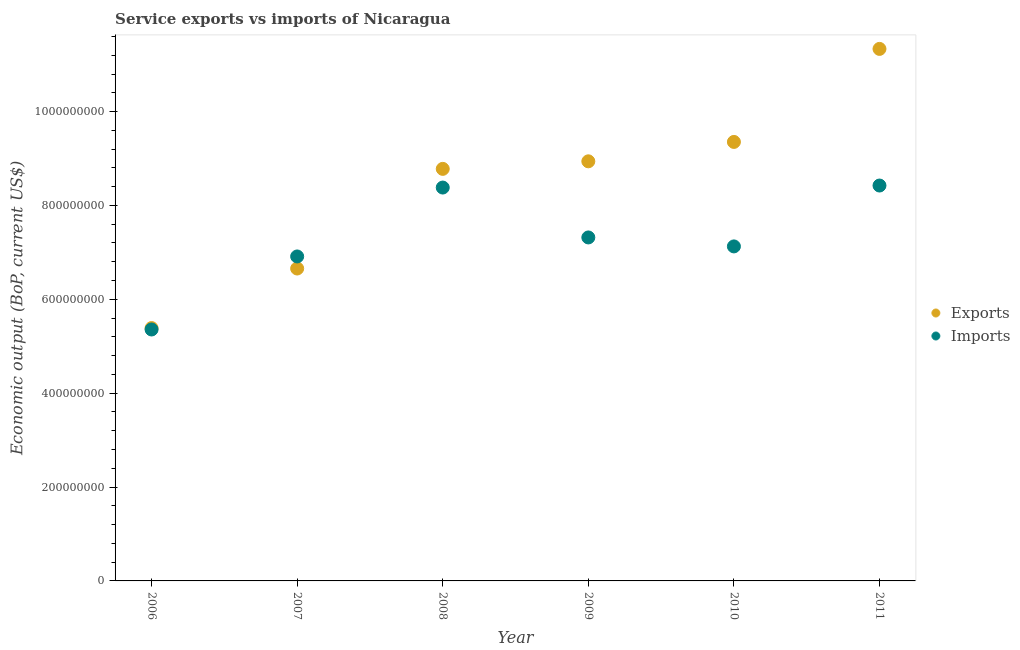How many different coloured dotlines are there?
Make the answer very short. 2. Is the number of dotlines equal to the number of legend labels?
Offer a very short reply. Yes. What is the amount of service exports in 2006?
Give a very brief answer. 5.39e+08. Across all years, what is the maximum amount of service imports?
Make the answer very short. 8.42e+08. Across all years, what is the minimum amount of service exports?
Your answer should be very brief. 5.39e+08. In which year was the amount of service exports maximum?
Your response must be concise. 2011. What is the total amount of service imports in the graph?
Provide a succinct answer. 4.35e+09. What is the difference between the amount of service exports in 2009 and that in 2010?
Provide a short and direct response. -4.13e+07. What is the difference between the amount of service exports in 2011 and the amount of service imports in 2007?
Provide a short and direct response. 4.42e+08. What is the average amount of service exports per year?
Your answer should be very brief. 8.41e+08. In the year 2007, what is the difference between the amount of service imports and amount of service exports?
Offer a terse response. 2.57e+07. In how many years, is the amount of service imports greater than 1080000000 US$?
Your response must be concise. 0. What is the ratio of the amount of service imports in 2007 to that in 2011?
Offer a very short reply. 0.82. What is the difference between the highest and the second highest amount of service imports?
Provide a succinct answer. 4.30e+06. What is the difference between the highest and the lowest amount of service exports?
Ensure brevity in your answer.  5.95e+08. Is the sum of the amount of service exports in 2008 and 2009 greater than the maximum amount of service imports across all years?
Give a very brief answer. Yes. How many dotlines are there?
Offer a very short reply. 2. Are the values on the major ticks of Y-axis written in scientific E-notation?
Your answer should be very brief. No. Does the graph contain grids?
Give a very brief answer. No. Where does the legend appear in the graph?
Provide a short and direct response. Center right. What is the title of the graph?
Keep it short and to the point. Service exports vs imports of Nicaragua. Does "Travel Items" appear as one of the legend labels in the graph?
Ensure brevity in your answer.  No. What is the label or title of the Y-axis?
Your answer should be compact. Economic output (BoP, current US$). What is the Economic output (BoP, current US$) of Exports in 2006?
Make the answer very short. 5.39e+08. What is the Economic output (BoP, current US$) of Imports in 2006?
Provide a succinct answer. 5.36e+08. What is the Economic output (BoP, current US$) in Exports in 2007?
Your answer should be compact. 6.66e+08. What is the Economic output (BoP, current US$) in Imports in 2007?
Give a very brief answer. 6.91e+08. What is the Economic output (BoP, current US$) of Exports in 2008?
Keep it short and to the point. 8.78e+08. What is the Economic output (BoP, current US$) in Imports in 2008?
Your answer should be very brief. 8.38e+08. What is the Economic output (BoP, current US$) of Exports in 2009?
Offer a terse response. 8.94e+08. What is the Economic output (BoP, current US$) in Imports in 2009?
Give a very brief answer. 7.32e+08. What is the Economic output (BoP, current US$) in Exports in 2010?
Offer a very short reply. 9.35e+08. What is the Economic output (BoP, current US$) of Imports in 2010?
Your response must be concise. 7.13e+08. What is the Economic output (BoP, current US$) of Exports in 2011?
Provide a succinct answer. 1.13e+09. What is the Economic output (BoP, current US$) in Imports in 2011?
Provide a succinct answer. 8.42e+08. Across all years, what is the maximum Economic output (BoP, current US$) in Exports?
Make the answer very short. 1.13e+09. Across all years, what is the maximum Economic output (BoP, current US$) in Imports?
Keep it short and to the point. 8.42e+08. Across all years, what is the minimum Economic output (BoP, current US$) of Exports?
Ensure brevity in your answer.  5.39e+08. Across all years, what is the minimum Economic output (BoP, current US$) in Imports?
Keep it short and to the point. 5.36e+08. What is the total Economic output (BoP, current US$) in Exports in the graph?
Keep it short and to the point. 5.04e+09. What is the total Economic output (BoP, current US$) in Imports in the graph?
Offer a very short reply. 4.35e+09. What is the difference between the Economic output (BoP, current US$) in Exports in 2006 and that in 2007?
Provide a succinct answer. -1.27e+08. What is the difference between the Economic output (BoP, current US$) of Imports in 2006 and that in 2007?
Offer a terse response. -1.56e+08. What is the difference between the Economic output (BoP, current US$) in Exports in 2006 and that in 2008?
Give a very brief answer. -3.39e+08. What is the difference between the Economic output (BoP, current US$) in Imports in 2006 and that in 2008?
Give a very brief answer. -3.02e+08. What is the difference between the Economic output (BoP, current US$) in Exports in 2006 and that in 2009?
Ensure brevity in your answer.  -3.55e+08. What is the difference between the Economic output (BoP, current US$) in Imports in 2006 and that in 2009?
Keep it short and to the point. -1.96e+08. What is the difference between the Economic output (BoP, current US$) in Exports in 2006 and that in 2010?
Your response must be concise. -3.97e+08. What is the difference between the Economic output (BoP, current US$) in Imports in 2006 and that in 2010?
Your response must be concise. -1.77e+08. What is the difference between the Economic output (BoP, current US$) of Exports in 2006 and that in 2011?
Provide a short and direct response. -5.95e+08. What is the difference between the Economic output (BoP, current US$) in Imports in 2006 and that in 2011?
Provide a short and direct response. -3.07e+08. What is the difference between the Economic output (BoP, current US$) in Exports in 2007 and that in 2008?
Provide a succinct answer. -2.12e+08. What is the difference between the Economic output (BoP, current US$) of Imports in 2007 and that in 2008?
Ensure brevity in your answer.  -1.47e+08. What is the difference between the Economic output (BoP, current US$) of Exports in 2007 and that in 2009?
Offer a very short reply. -2.28e+08. What is the difference between the Economic output (BoP, current US$) of Imports in 2007 and that in 2009?
Ensure brevity in your answer.  -4.05e+07. What is the difference between the Economic output (BoP, current US$) in Exports in 2007 and that in 2010?
Offer a very short reply. -2.70e+08. What is the difference between the Economic output (BoP, current US$) in Imports in 2007 and that in 2010?
Keep it short and to the point. -2.14e+07. What is the difference between the Economic output (BoP, current US$) in Exports in 2007 and that in 2011?
Your answer should be very brief. -4.68e+08. What is the difference between the Economic output (BoP, current US$) in Imports in 2007 and that in 2011?
Your response must be concise. -1.51e+08. What is the difference between the Economic output (BoP, current US$) in Exports in 2008 and that in 2009?
Your response must be concise. -1.61e+07. What is the difference between the Economic output (BoP, current US$) of Imports in 2008 and that in 2009?
Make the answer very short. 1.06e+08. What is the difference between the Economic output (BoP, current US$) of Exports in 2008 and that in 2010?
Provide a short and direct response. -5.74e+07. What is the difference between the Economic output (BoP, current US$) in Imports in 2008 and that in 2010?
Keep it short and to the point. 1.25e+08. What is the difference between the Economic output (BoP, current US$) in Exports in 2008 and that in 2011?
Keep it short and to the point. -2.56e+08. What is the difference between the Economic output (BoP, current US$) in Imports in 2008 and that in 2011?
Ensure brevity in your answer.  -4.30e+06. What is the difference between the Economic output (BoP, current US$) in Exports in 2009 and that in 2010?
Make the answer very short. -4.13e+07. What is the difference between the Economic output (BoP, current US$) of Imports in 2009 and that in 2010?
Ensure brevity in your answer.  1.91e+07. What is the difference between the Economic output (BoP, current US$) in Exports in 2009 and that in 2011?
Offer a very short reply. -2.40e+08. What is the difference between the Economic output (BoP, current US$) of Imports in 2009 and that in 2011?
Ensure brevity in your answer.  -1.11e+08. What is the difference between the Economic output (BoP, current US$) in Exports in 2010 and that in 2011?
Make the answer very short. -1.98e+08. What is the difference between the Economic output (BoP, current US$) in Imports in 2010 and that in 2011?
Give a very brief answer. -1.30e+08. What is the difference between the Economic output (BoP, current US$) of Exports in 2006 and the Economic output (BoP, current US$) of Imports in 2007?
Provide a short and direct response. -1.53e+08. What is the difference between the Economic output (BoP, current US$) of Exports in 2006 and the Economic output (BoP, current US$) of Imports in 2008?
Make the answer very short. -2.99e+08. What is the difference between the Economic output (BoP, current US$) in Exports in 2006 and the Economic output (BoP, current US$) in Imports in 2009?
Give a very brief answer. -1.93e+08. What is the difference between the Economic output (BoP, current US$) in Exports in 2006 and the Economic output (BoP, current US$) in Imports in 2010?
Offer a very short reply. -1.74e+08. What is the difference between the Economic output (BoP, current US$) in Exports in 2006 and the Economic output (BoP, current US$) in Imports in 2011?
Give a very brief answer. -3.04e+08. What is the difference between the Economic output (BoP, current US$) of Exports in 2007 and the Economic output (BoP, current US$) of Imports in 2008?
Your answer should be very brief. -1.72e+08. What is the difference between the Economic output (BoP, current US$) of Exports in 2007 and the Economic output (BoP, current US$) of Imports in 2009?
Ensure brevity in your answer.  -6.62e+07. What is the difference between the Economic output (BoP, current US$) in Exports in 2007 and the Economic output (BoP, current US$) in Imports in 2010?
Provide a succinct answer. -4.71e+07. What is the difference between the Economic output (BoP, current US$) in Exports in 2007 and the Economic output (BoP, current US$) in Imports in 2011?
Offer a very short reply. -1.77e+08. What is the difference between the Economic output (BoP, current US$) of Exports in 2008 and the Economic output (BoP, current US$) of Imports in 2009?
Your answer should be compact. 1.46e+08. What is the difference between the Economic output (BoP, current US$) of Exports in 2008 and the Economic output (BoP, current US$) of Imports in 2010?
Provide a succinct answer. 1.65e+08. What is the difference between the Economic output (BoP, current US$) of Exports in 2008 and the Economic output (BoP, current US$) of Imports in 2011?
Provide a short and direct response. 3.55e+07. What is the difference between the Economic output (BoP, current US$) of Exports in 2009 and the Economic output (BoP, current US$) of Imports in 2010?
Ensure brevity in your answer.  1.81e+08. What is the difference between the Economic output (BoP, current US$) of Exports in 2009 and the Economic output (BoP, current US$) of Imports in 2011?
Provide a succinct answer. 5.16e+07. What is the difference between the Economic output (BoP, current US$) of Exports in 2010 and the Economic output (BoP, current US$) of Imports in 2011?
Provide a succinct answer. 9.29e+07. What is the average Economic output (BoP, current US$) in Exports per year?
Offer a very short reply. 8.41e+08. What is the average Economic output (BoP, current US$) in Imports per year?
Your response must be concise. 7.25e+08. In the year 2006, what is the difference between the Economic output (BoP, current US$) of Exports and Economic output (BoP, current US$) of Imports?
Ensure brevity in your answer.  3.00e+06. In the year 2007, what is the difference between the Economic output (BoP, current US$) in Exports and Economic output (BoP, current US$) in Imports?
Keep it short and to the point. -2.57e+07. In the year 2008, what is the difference between the Economic output (BoP, current US$) in Exports and Economic output (BoP, current US$) in Imports?
Make the answer very short. 3.98e+07. In the year 2009, what is the difference between the Economic output (BoP, current US$) of Exports and Economic output (BoP, current US$) of Imports?
Your answer should be very brief. 1.62e+08. In the year 2010, what is the difference between the Economic output (BoP, current US$) in Exports and Economic output (BoP, current US$) in Imports?
Your answer should be compact. 2.23e+08. In the year 2011, what is the difference between the Economic output (BoP, current US$) of Exports and Economic output (BoP, current US$) of Imports?
Keep it short and to the point. 2.91e+08. What is the ratio of the Economic output (BoP, current US$) in Exports in 2006 to that in 2007?
Keep it short and to the point. 0.81. What is the ratio of the Economic output (BoP, current US$) in Imports in 2006 to that in 2007?
Make the answer very short. 0.77. What is the ratio of the Economic output (BoP, current US$) of Exports in 2006 to that in 2008?
Provide a succinct answer. 0.61. What is the ratio of the Economic output (BoP, current US$) of Imports in 2006 to that in 2008?
Give a very brief answer. 0.64. What is the ratio of the Economic output (BoP, current US$) in Exports in 2006 to that in 2009?
Your response must be concise. 0.6. What is the ratio of the Economic output (BoP, current US$) of Imports in 2006 to that in 2009?
Ensure brevity in your answer.  0.73. What is the ratio of the Economic output (BoP, current US$) in Exports in 2006 to that in 2010?
Offer a very short reply. 0.58. What is the ratio of the Economic output (BoP, current US$) in Imports in 2006 to that in 2010?
Your answer should be very brief. 0.75. What is the ratio of the Economic output (BoP, current US$) in Exports in 2006 to that in 2011?
Offer a very short reply. 0.48. What is the ratio of the Economic output (BoP, current US$) of Imports in 2006 to that in 2011?
Your answer should be very brief. 0.64. What is the ratio of the Economic output (BoP, current US$) of Exports in 2007 to that in 2008?
Provide a short and direct response. 0.76. What is the ratio of the Economic output (BoP, current US$) in Imports in 2007 to that in 2008?
Your response must be concise. 0.82. What is the ratio of the Economic output (BoP, current US$) in Exports in 2007 to that in 2009?
Provide a short and direct response. 0.74. What is the ratio of the Economic output (BoP, current US$) in Imports in 2007 to that in 2009?
Keep it short and to the point. 0.94. What is the ratio of the Economic output (BoP, current US$) of Exports in 2007 to that in 2010?
Your answer should be very brief. 0.71. What is the ratio of the Economic output (BoP, current US$) of Imports in 2007 to that in 2010?
Your response must be concise. 0.97. What is the ratio of the Economic output (BoP, current US$) of Exports in 2007 to that in 2011?
Your response must be concise. 0.59. What is the ratio of the Economic output (BoP, current US$) in Imports in 2007 to that in 2011?
Your response must be concise. 0.82. What is the ratio of the Economic output (BoP, current US$) in Exports in 2008 to that in 2009?
Make the answer very short. 0.98. What is the ratio of the Economic output (BoP, current US$) in Imports in 2008 to that in 2009?
Your answer should be compact. 1.15. What is the ratio of the Economic output (BoP, current US$) of Exports in 2008 to that in 2010?
Provide a short and direct response. 0.94. What is the ratio of the Economic output (BoP, current US$) in Imports in 2008 to that in 2010?
Your answer should be very brief. 1.18. What is the ratio of the Economic output (BoP, current US$) in Exports in 2008 to that in 2011?
Keep it short and to the point. 0.77. What is the ratio of the Economic output (BoP, current US$) in Exports in 2009 to that in 2010?
Your answer should be compact. 0.96. What is the ratio of the Economic output (BoP, current US$) in Imports in 2009 to that in 2010?
Ensure brevity in your answer.  1.03. What is the ratio of the Economic output (BoP, current US$) in Exports in 2009 to that in 2011?
Make the answer very short. 0.79. What is the ratio of the Economic output (BoP, current US$) in Imports in 2009 to that in 2011?
Ensure brevity in your answer.  0.87. What is the ratio of the Economic output (BoP, current US$) of Exports in 2010 to that in 2011?
Offer a terse response. 0.83. What is the ratio of the Economic output (BoP, current US$) of Imports in 2010 to that in 2011?
Offer a very short reply. 0.85. What is the difference between the highest and the second highest Economic output (BoP, current US$) in Exports?
Keep it short and to the point. 1.98e+08. What is the difference between the highest and the second highest Economic output (BoP, current US$) in Imports?
Offer a terse response. 4.30e+06. What is the difference between the highest and the lowest Economic output (BoP, current US$) of Exports?
Your answer should be compact. 5.95e+08. What is the difference between the highest and the lowest Economic output (BoP, current US$) of Imports?
Your answer should be very brief. 3.07e+08. 